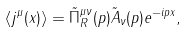<formula> <loc_0><loc_0><loc_500><loc_500>\langle j ^ { \mu } ( x ) \rangle = \tilde { \Pi } ^ { \mu \nu } _ { R } ( p ) \tilde { A } _ { \nu } ( p ) e ^ { - i p x } ,</formula> 